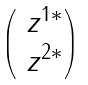<formula> <loc_0><loc_0><loc_500><loc_500>\begin{pmatrix} \ z ^ { 1 * } \\ \ z ^ { 2 * } \end{pmatrix}</formula> 